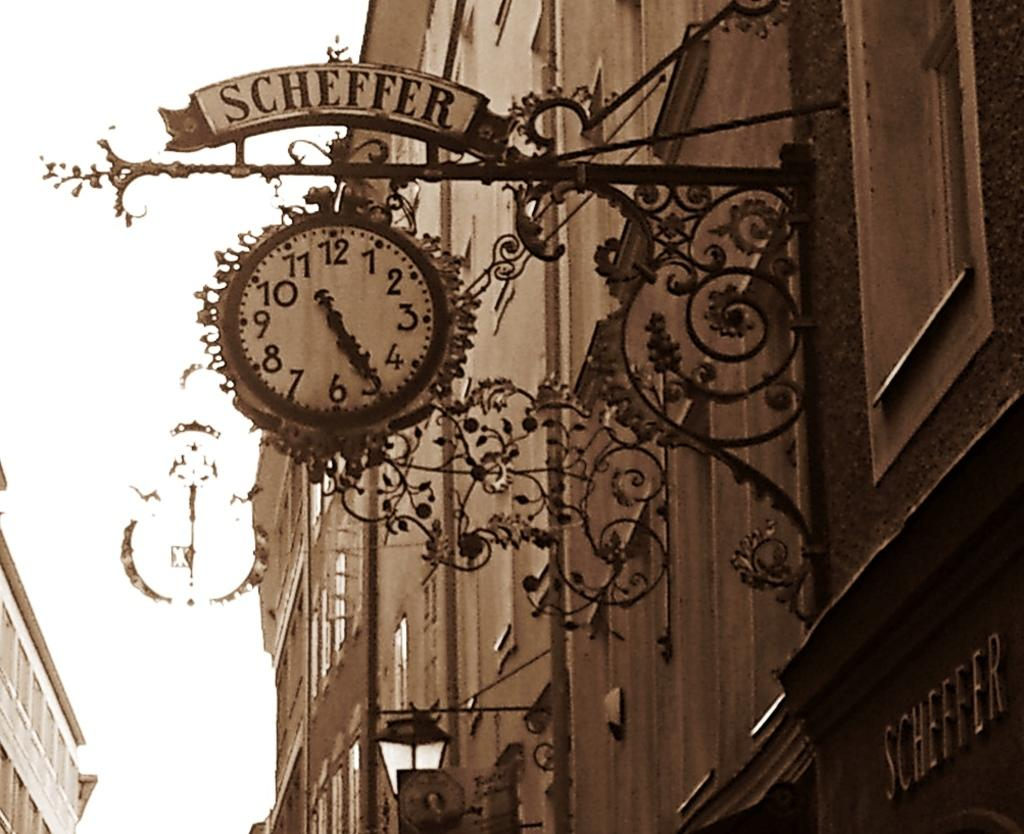<image>
Render a clear and concise summary of the photo. The clock at Scheffer shows that it is 11:25. 